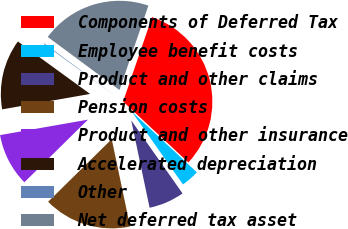Convert chart. <chart><loc_0><loc_0><loc_500><loc_500><pie_chart><fcel>Components of Deferred Tax<fcel>Employee benefit costs<fcel>Product and other claims<fcel>Pension costs<fcel>Product and other insurance<fcel>Accelerated depreciation<fcel>Other<fcel>Net deferred tax asset<nl><fcel>31.7%<fcel>3.3%<fcel>6.45%<fcel>15.92%<fcel>9.61%<fcel>12.77%<fcel>0.14%<fcel>20.11%<nl></chart> 